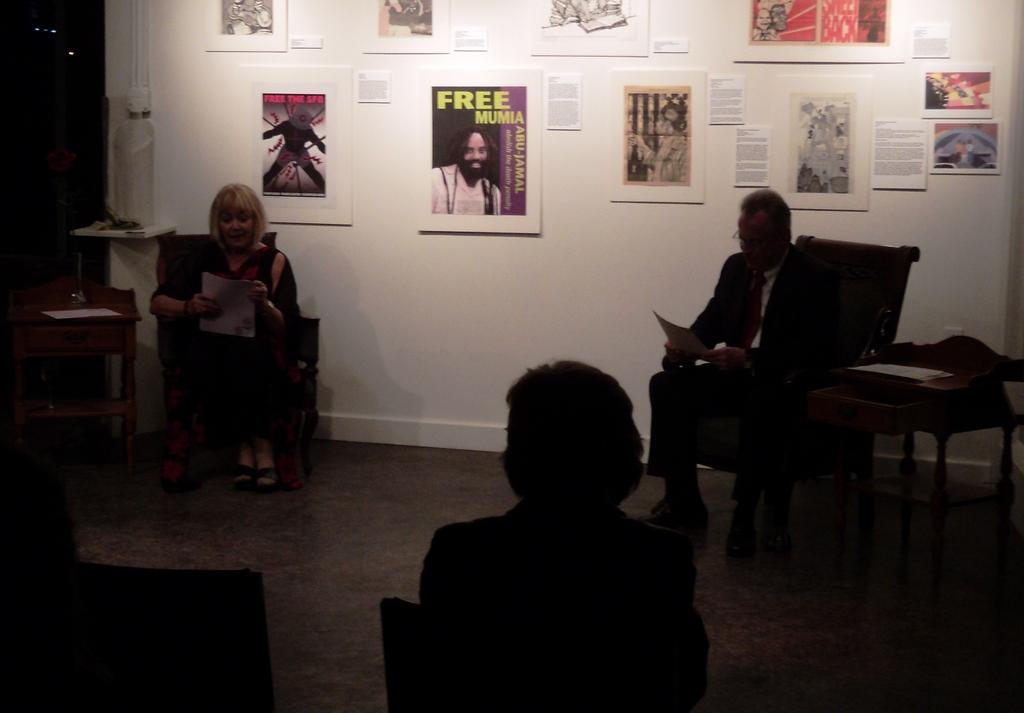How many people are sitting in chairs in the image? There are three persons sitting in chairs in the image. What is the primary piece of furniture in the image? There is a table in the image. What can be seen on the wall in the image? There are photo frames attached to the wall. Can you see a giraffe in the image? No, there is no giraffe present in the image. What type of amusement can be seen in the image? There is no amusement depicted in the image; it features three persons sitting in chairs, a table, and photo frames on the wall. 